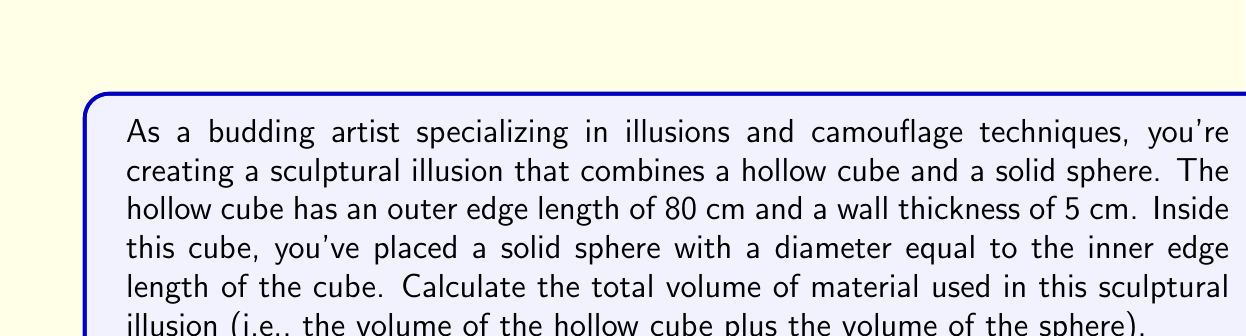Teach me how to tackle this problem. Let's break this down step-by-step:

1. Calculate the inner edge length of the cube:
   Outer edge length = 80 cm
   Wall thickness = 5 cm
   Inner edge length = 80 - (2 * 5) = 70 cm

2. Calculate the volume of the hollow cube:
   $$V_{cube} = V_{outer} - V_{inner}$$
   $$V_{outer} = 80^3 = 512,000 \text{ cm}^3$$
   $$V_{inner} = 70^3 = 343,000 \text{ cm}^3$$
   $$V_{cube} = 512,000 - 343,000 = 169,000 \text{ cm}^3$$

3. Calculate the volume of the sphere:
   The diameter of the sphere equals the inner edge length of the cube, so its radius is half of that.
   Radius = 70 / 2 = 35 cm
   $$V_{sphere} = \frac{4}{3}\pi r^3 = \frac{4}{3}\pi (35)^3 \approx 179,594 \text{ cm}^3$$

4. Sum the volumes:
   Total volume = $V_{cube} + V_{sphere}$
   $$169,000 + 179,594 = 348,594 \text{ cm}^3$$

[asy]
import three;

size(200);
currentprojection=perspective(6,3,2);

// Draw outer cube
draw(box((0,0,0),(80,80,80)),rgb(0.8,0.8,0.8)+opacity(0.3));

// Draw inner cube
draw(box((5,5,5),(75,75,75)),rgb(0.8,0.8,0.8)+opacity(0.3));

// Draw sphere
draw(sphere((40,40,40),35),rgb(1,0.7,0.7));
[/asy]
Answer: The total volume of material used in the sculptural illusion is approximately 348,594 cm³. 